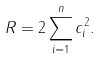<formula> <loc_0><loc_0><loc_500><loc_500>R = 2 \sum _ { i = 1 } ^ { n } c _ { i } ^ { 2 } .</formula> 